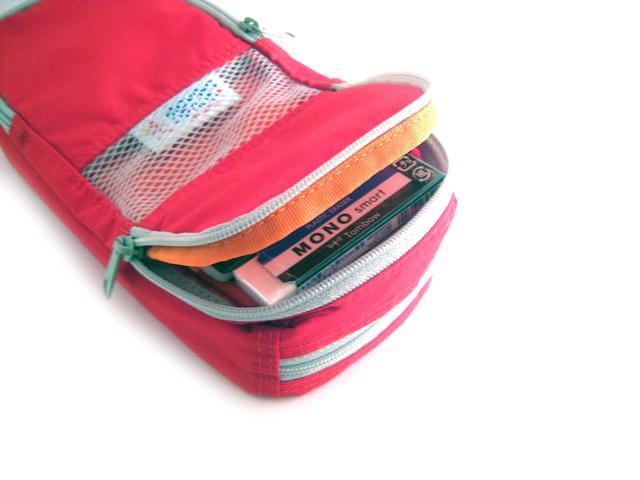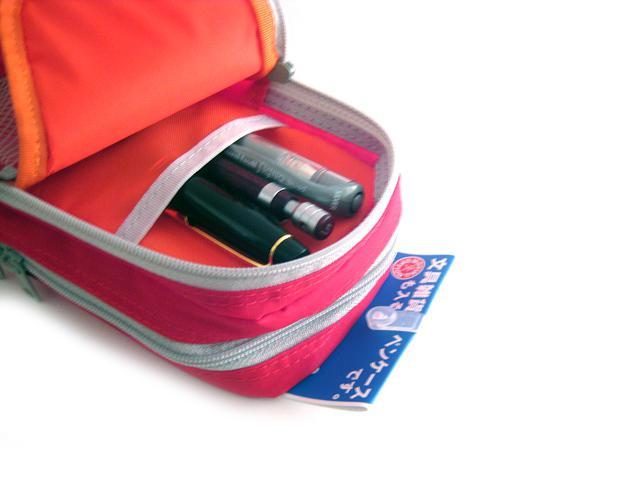The first image is the image on the left, the second image is the image on the right. Evaluate the accuracy of this statement regarding the images: "A hand is opening the pencil case in at least one image.". Is it true? Answer yes or no. No. The first image is the image on the left, the second image is the image on the right. Examine the images to the left and right. Is the description "At least one of the images has a hand holding the pouch open." accurate? Answer yes or no. No. 